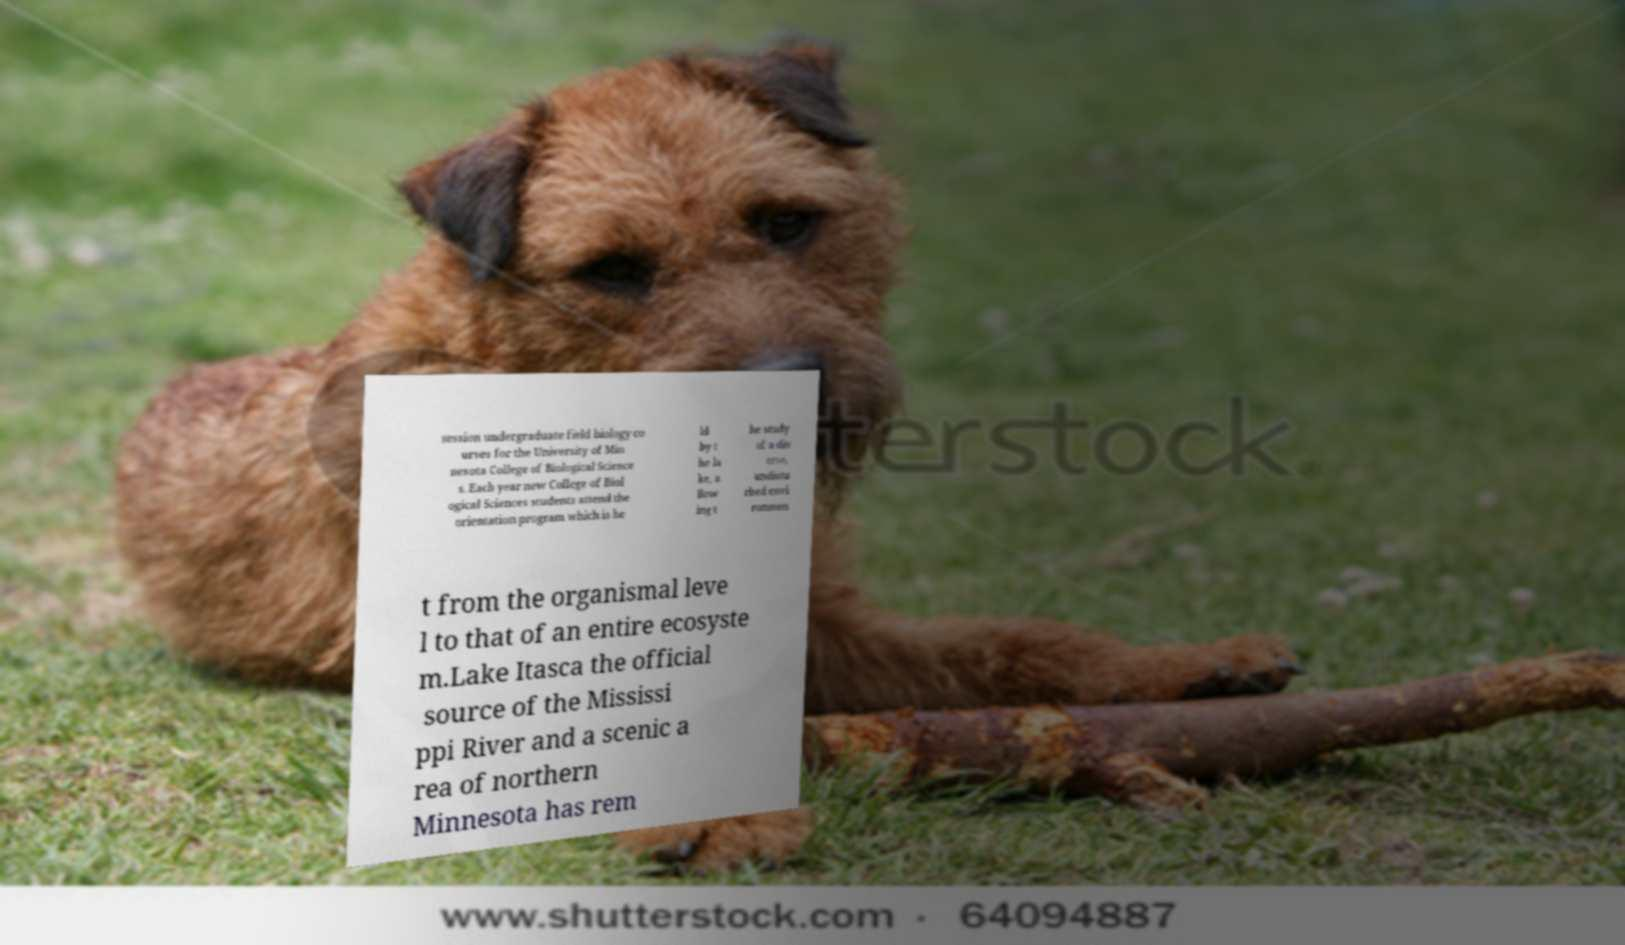Could you assist in decoding the text presented in this image and type it out clearly? session undergraduate field biology co urses for the University of Min nesota College of Biological Science s. Each year new College of Biol ogical Sciences students attend the orientation program which is he ld by t he la ke, a llow ing t he study of a div erse, undistu rbed envi ronmen t from the organismal leve l to that of an entire ecosyste m.Lake Itasca the official source of the Mississi ppi River and a scenic a rea of northern Minnesota has rem 